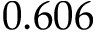Convert formula to latex. <formula><loc_0><loc_0><loc_500><loc_500>0 . 6 0 6</formula> 